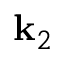Convert formula to latex. <formula><loc_0><loc_0><loc_500><loc_500>k _ { 2 }</formula> 